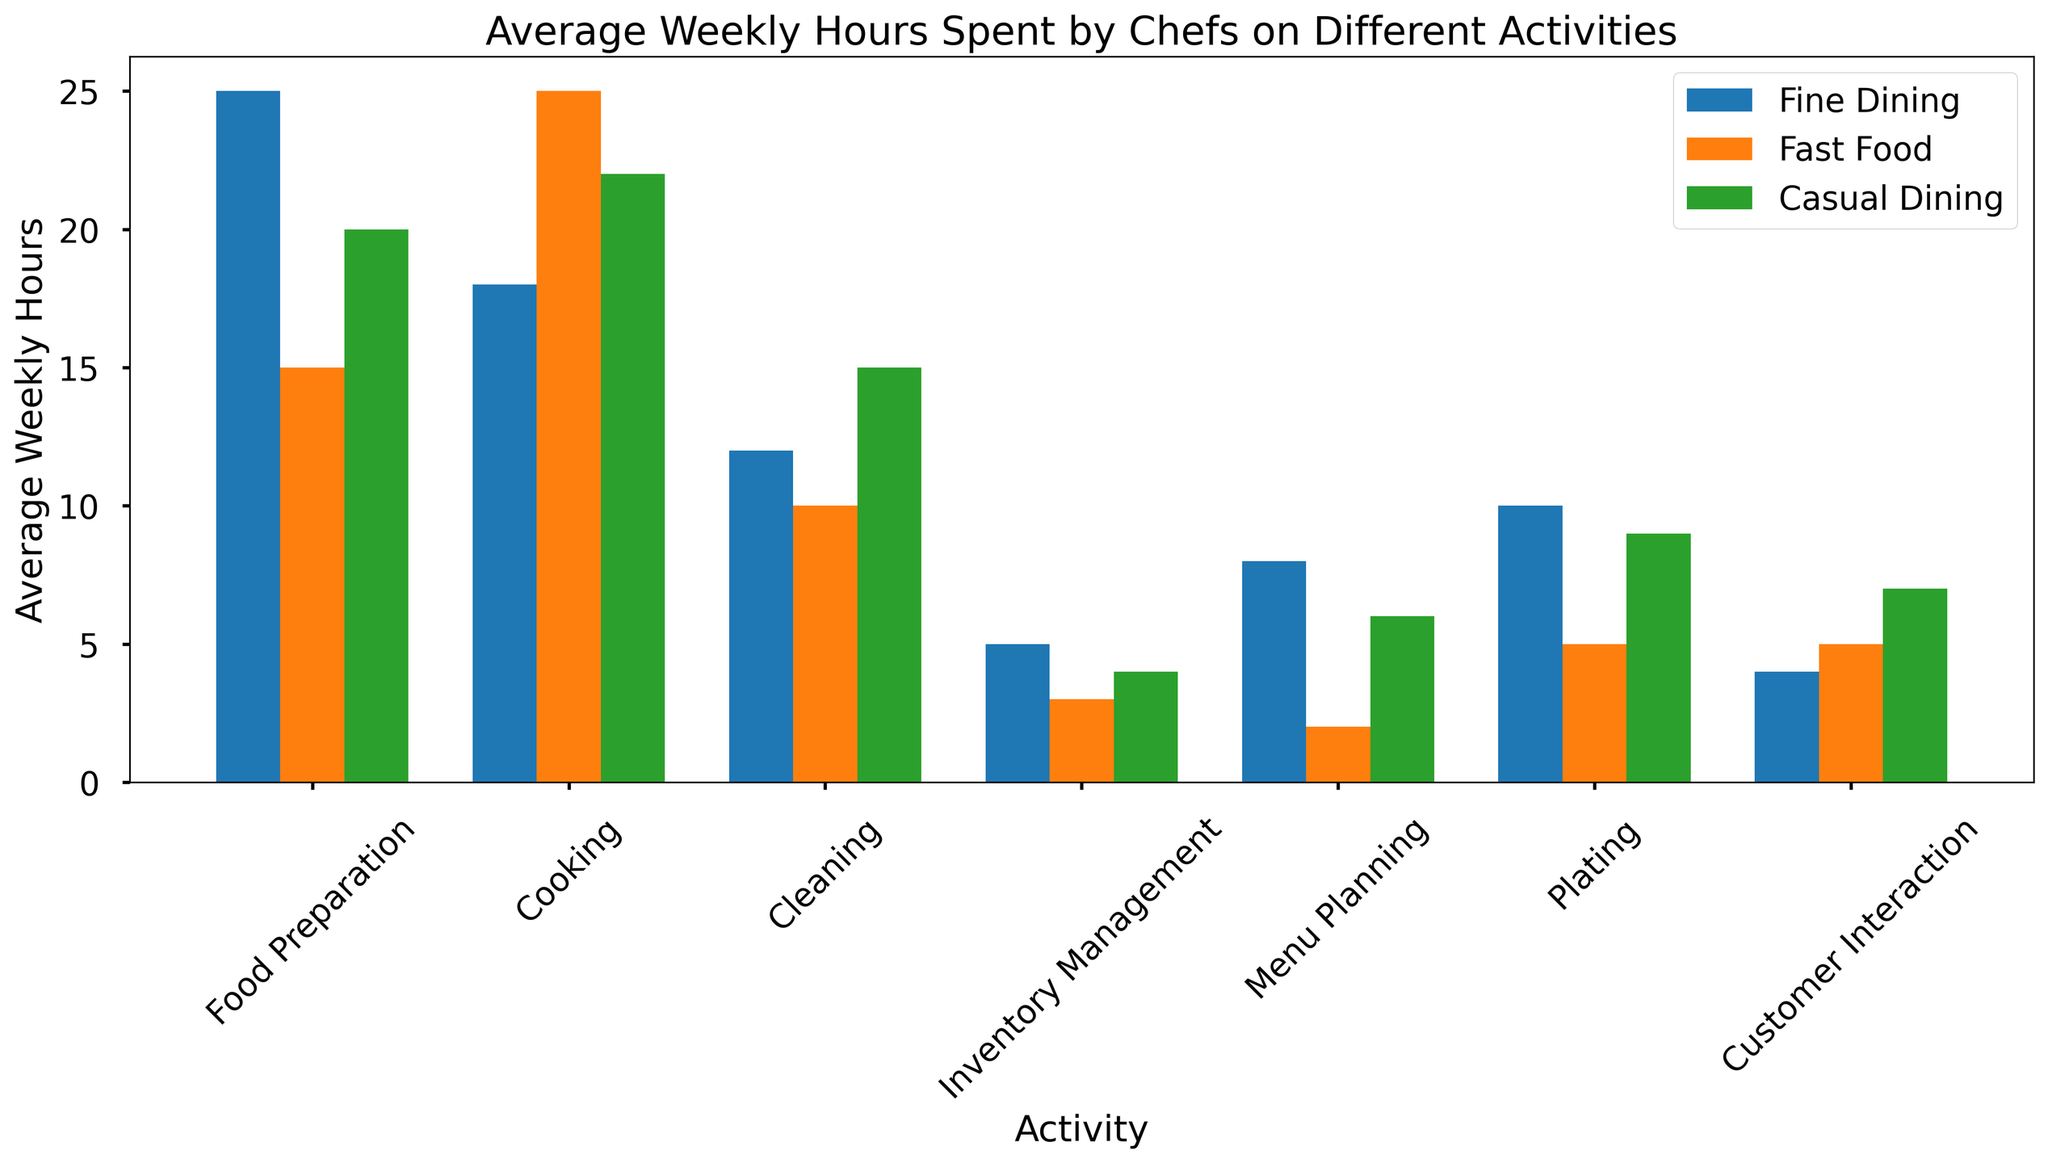Which restaurant type spends the most hours on food preparation? To find the answer, look at the heights of the bars corresponding to "Food Preparation" for all restaurant types. The "Fine Dining" bar is the tallest, indicating it has the highest average weekly hours.
Answer: Fine Dining Which activity has the least average weekly hours across all restaurant types? Examine all bars to find the smallest height. “Inventory Management” in Fast Food (3 hours) is the smallest value across all activities and restaurant types.
Answer: Inventory Management How many more hours does fine dining spend on cooking compared to fast food? Find the heights of the bars for "Cooking" for Fine Dining (18) and Fast Food (25). Calculate the difference (25 - 18 = 7).
Answer: 7 hours Which activity in casual dining has the highest average weekly hours? For Casual Dining, inspect the heights of all activity bars. "Cooking" has the highest bar with 22 hours.
Answer: Cooking Compare the hours spent on cleaning between casual dining and fast food. Which spends more? Look at the heights of the "Cleaning" bars for Casual Dining (15) and Fast Food (10). Casual Dining is higher.
Answer: Casual Dining What is the total average weekly hours spent on customer interaction across all restaurant types? Add up the heights of the "Customer Interaction" bars for Fine Dining (4), Fast Food (5), and Casual Dining (7). The sum is 4 + 5 + 7 = 16.
Answer: 16 hours How do the hours spent on menu planning in fine dining compare to those in casual dining? Compare the heights of the "Menu Planning" bars for Fine Dining (8) and Casual Dining (6). Fine Dining has a higher bar.
Answer: Fine Dining What is the collective average weekly hours spent on plating in all restaurant types? Sum the "Plating" activity bars for Fine Dining (10), Fast Food (5), and Casual Dining (9). The total is 10 + 5 + 9 = 24.
Answer: 24 hours Which restaurant type dedicates the least time to inventory management? Look for the smallest "Inventory Management" bar among the restaurant types. Fast Food has the smallest bar at 3 hours.
Answer: Fast Food 